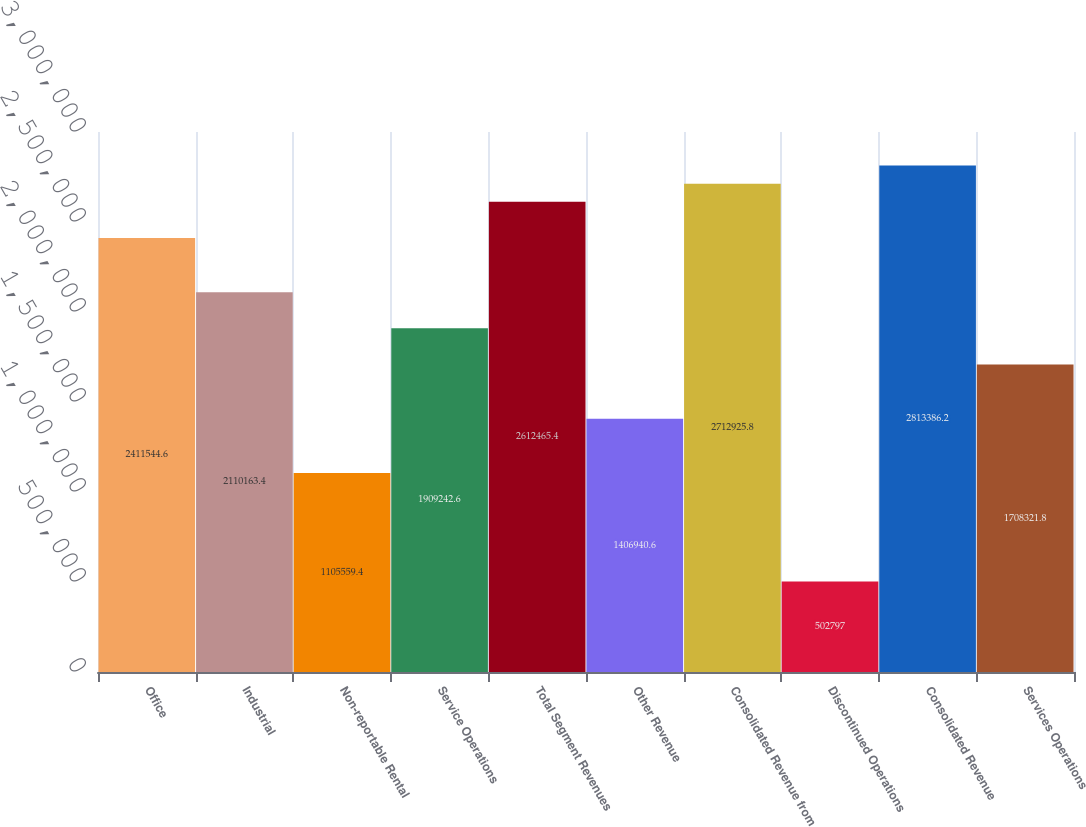Convert chart to OTSL. <chart><loc_0><loc_0><loc_500><loc_500><bar_chart><fcel>Office<fcel>Industrial<fcel>Non-reportable Rental<fcel>Service Operations<fcel>Total Segment Revenues<fcel>Other Revenue<fcel>Consolidated Revenue from<fcel>Discontinued Operations<fcel>Consolidated Revenue<fcel>Services Operations<nl><fcel>2.41154e+06<fcel>2.11016e+06<fcel>1.10556e+06<fcel>1.90924e+06<fcel>2.61247e+06<fcel>1.40694e+06<fcel>2.71293e+06<fcel>502797<fcel>2.81339e+06<fcel>1.70832e+06<nl></chart> 